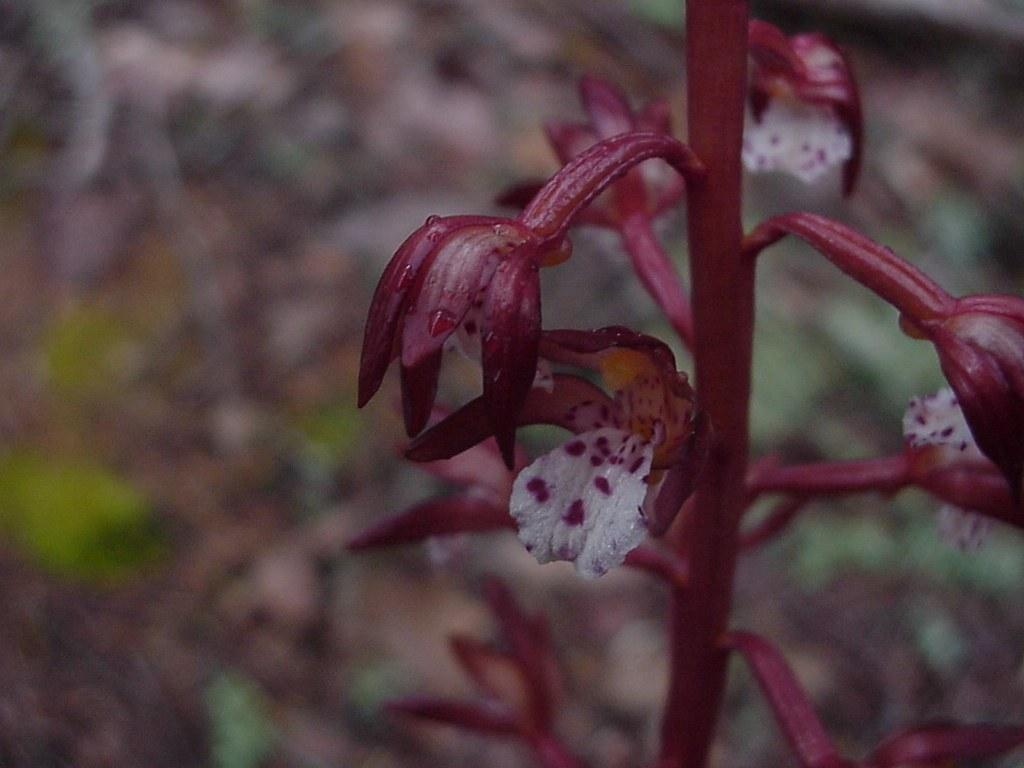What is the main subject of the image? The main subject of the image is a stem with flowers. Can you describe the background of the image? The background of the image is blurred. How many toes can be seen on the flowers in the image? There are no toes present in the image, as it features a stem with flowers. What type of whistle is being used by the flowers in the image? There is no whistle present in the image, as it features a stem with flowers. 